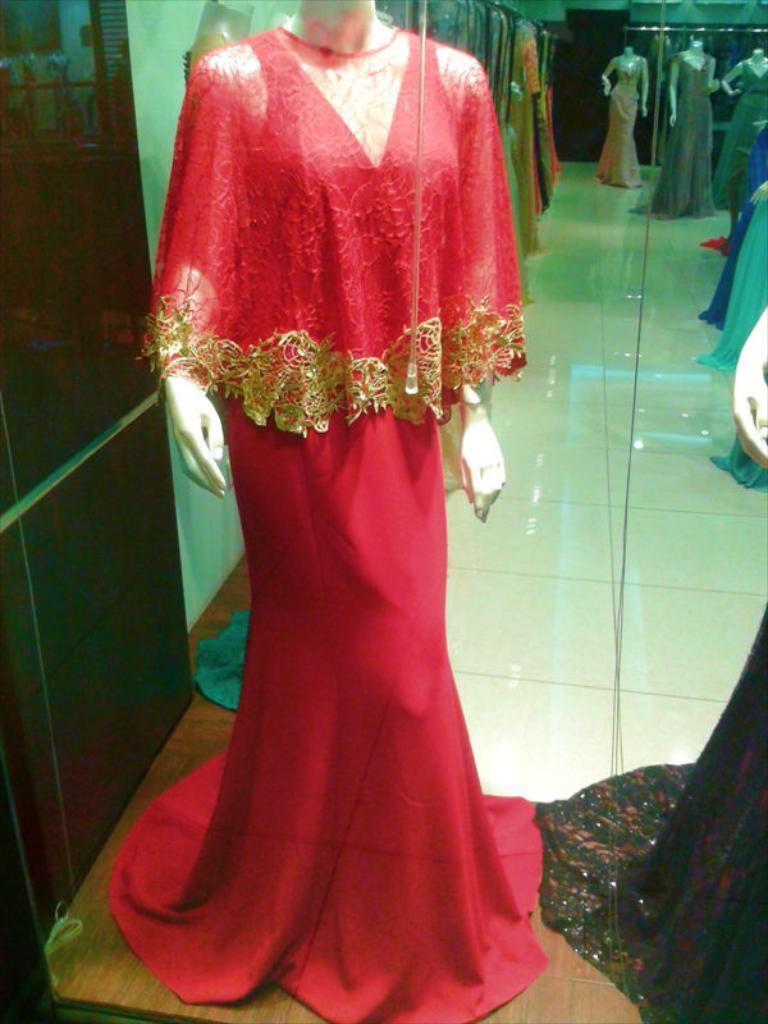Describe this image in one or two sentences. In the given image i can see a mannequins and floor. 